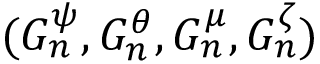<formula> <loc_0><loc_0><loc_500><loc_500>( G _ { n } ^ { \psi } , G _ { n } ^ { \theta } , G _ { n } ^ { \mu } , G _ { n } ^ { \zeta } )</formula> 